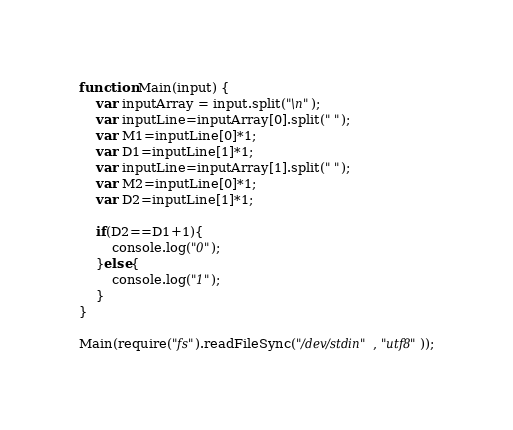<code> <loc_0><loc_0><loc_500><loc_500><_JavaScript_>function Main(input) {
   	var inputArray = input.split("\n");
	var inputLine=inputArray[0].split(" ");
	var M1=inputLine[0]*1;
	var D1=inputLine[1]*1;
	var inputLine=inputArray[1].split(" ");	
	var M2=inputLine[0]*1;
	var D2=inputLine[1]*1;
	
	if(D2==D1+1){
		console.log("0");
	}else{
		console.log("1");		
	}
}
     
Main(require("fs").readFileSync("/dev/stdin", "utf8"));</code> 